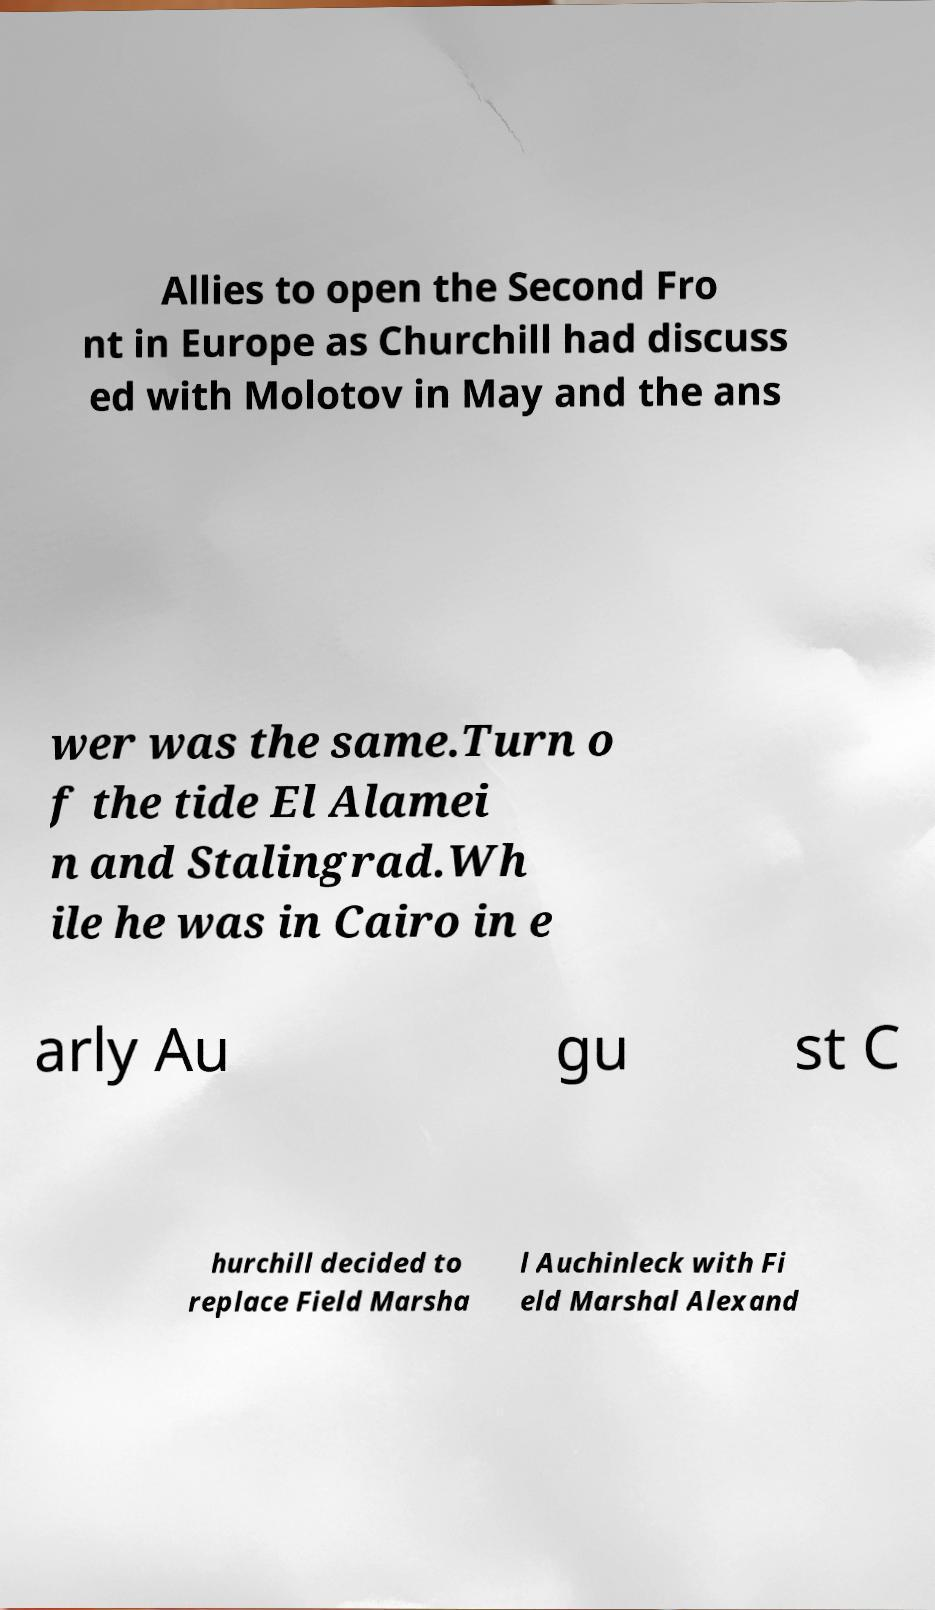Can you accurately transcribe the text from the provided image for me? Allies to open the Second Fro nt in Europe as Churchill had discuss ed with Molotov in May and the ans wer was the same.Turn o f the tide El Alamei n and Stalingrad.Wh ile he was in Cairo in e arly Au gu st C hurchill decided to replace Field Marsha l Auchinleck with Fi eld Marshal Alexand 